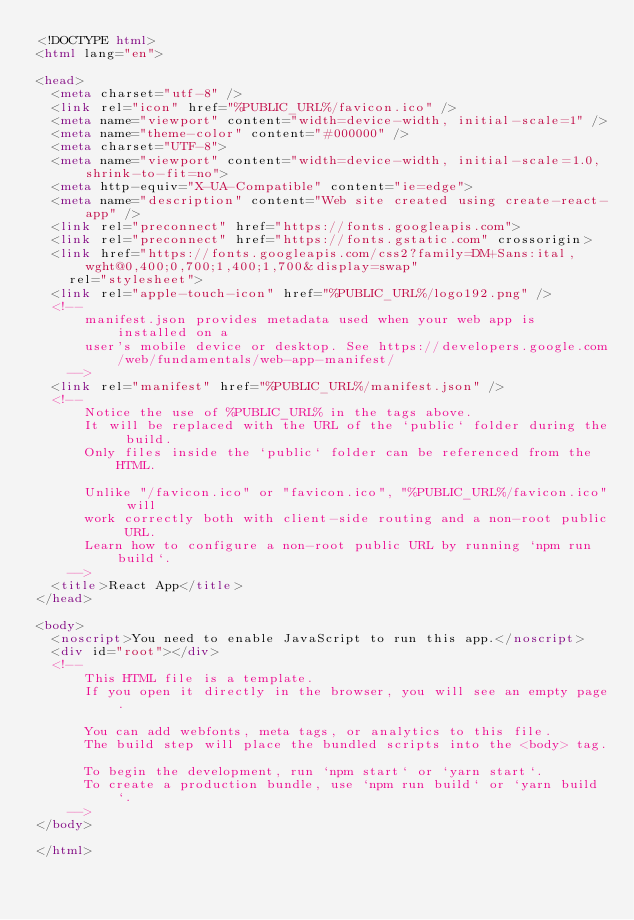Convert code to text. <code><loc_0><loc_0><loc_500><loc_500><_HTML_><!DOCTYPE html>
<html lang="en">

<head>
  <meta charset="utf-8" />
  <link rel="icon" href="%PUBLIC_URL%/favicon.ico" />
  <meta name="viewport" content="width=device-width, initial-scale=1" />
  <meta name="theme-color" content="#000000" />
  <meta charset="UTF-8">
  <meta name="viewport" content="width=device-width, initial-scale=1.0, shrink-to-fit=no">
  <meta http-equiv="X-UA-Compatible" content="ie=edge">
  <meta name="description" content="Web site created using create-react-app" />
  <link rel="preconnect" href="https://fonts.googleapis.com">
  <link rel="preconnect" href="https://fonts.gstatic.com" crossorigin>
  <link href="https://fonts.googleapis.com/css2?family=DM+Sans:ital,wght@0,400;0,700;1,400;1,700&display=swap"
    rel="stylesheet">
  <link rel="apple-touch-icon" href="%PUBLIC_URL%/logo192.png" />
  <!--
      manifest.json provides metadata used when your web app is installed on a
      user's mobile device or desktop. See https://developers.google.com/web/fundamentals/web-app-manifest/
    -->
  <link rel="manifest" href="%PUBLIC_URL%/manifest.json" />
  <!--
      Notice the use of %PUBLIC_URL% in the tags above.
      It will be replaced with the URL of the `public` folder during the build.
      Only files inside the `public` folder can be referenced from the HTML.

      Unlike "/favicon.ico" or "favicon.ico", "%PUBLIC_URL%/favicon.ico" will
      work correctly both with client-side routing and a non-root public URL.
      Learn how to configure a non-root public URL by running `npm run build`.
    -->
  <title>React App</title>
</head>

<body>
  <noscript>You need to enable JavaScript to run this app.</noscript>
  <div id="root"></div>
  <!--
      This HTML file is a template.
      If you open it directly in the browser, you will see an empty page.

      You can add webfonts, meta tags, or analytics to this file.
      The build step will place the bundled scripts into the <body> tag.

      To begin the development, run `npm start` or `yarn start`.
      To create a production bundle, use `npm run build` or `yarn build`.
    -->
</body>

</html></code> 